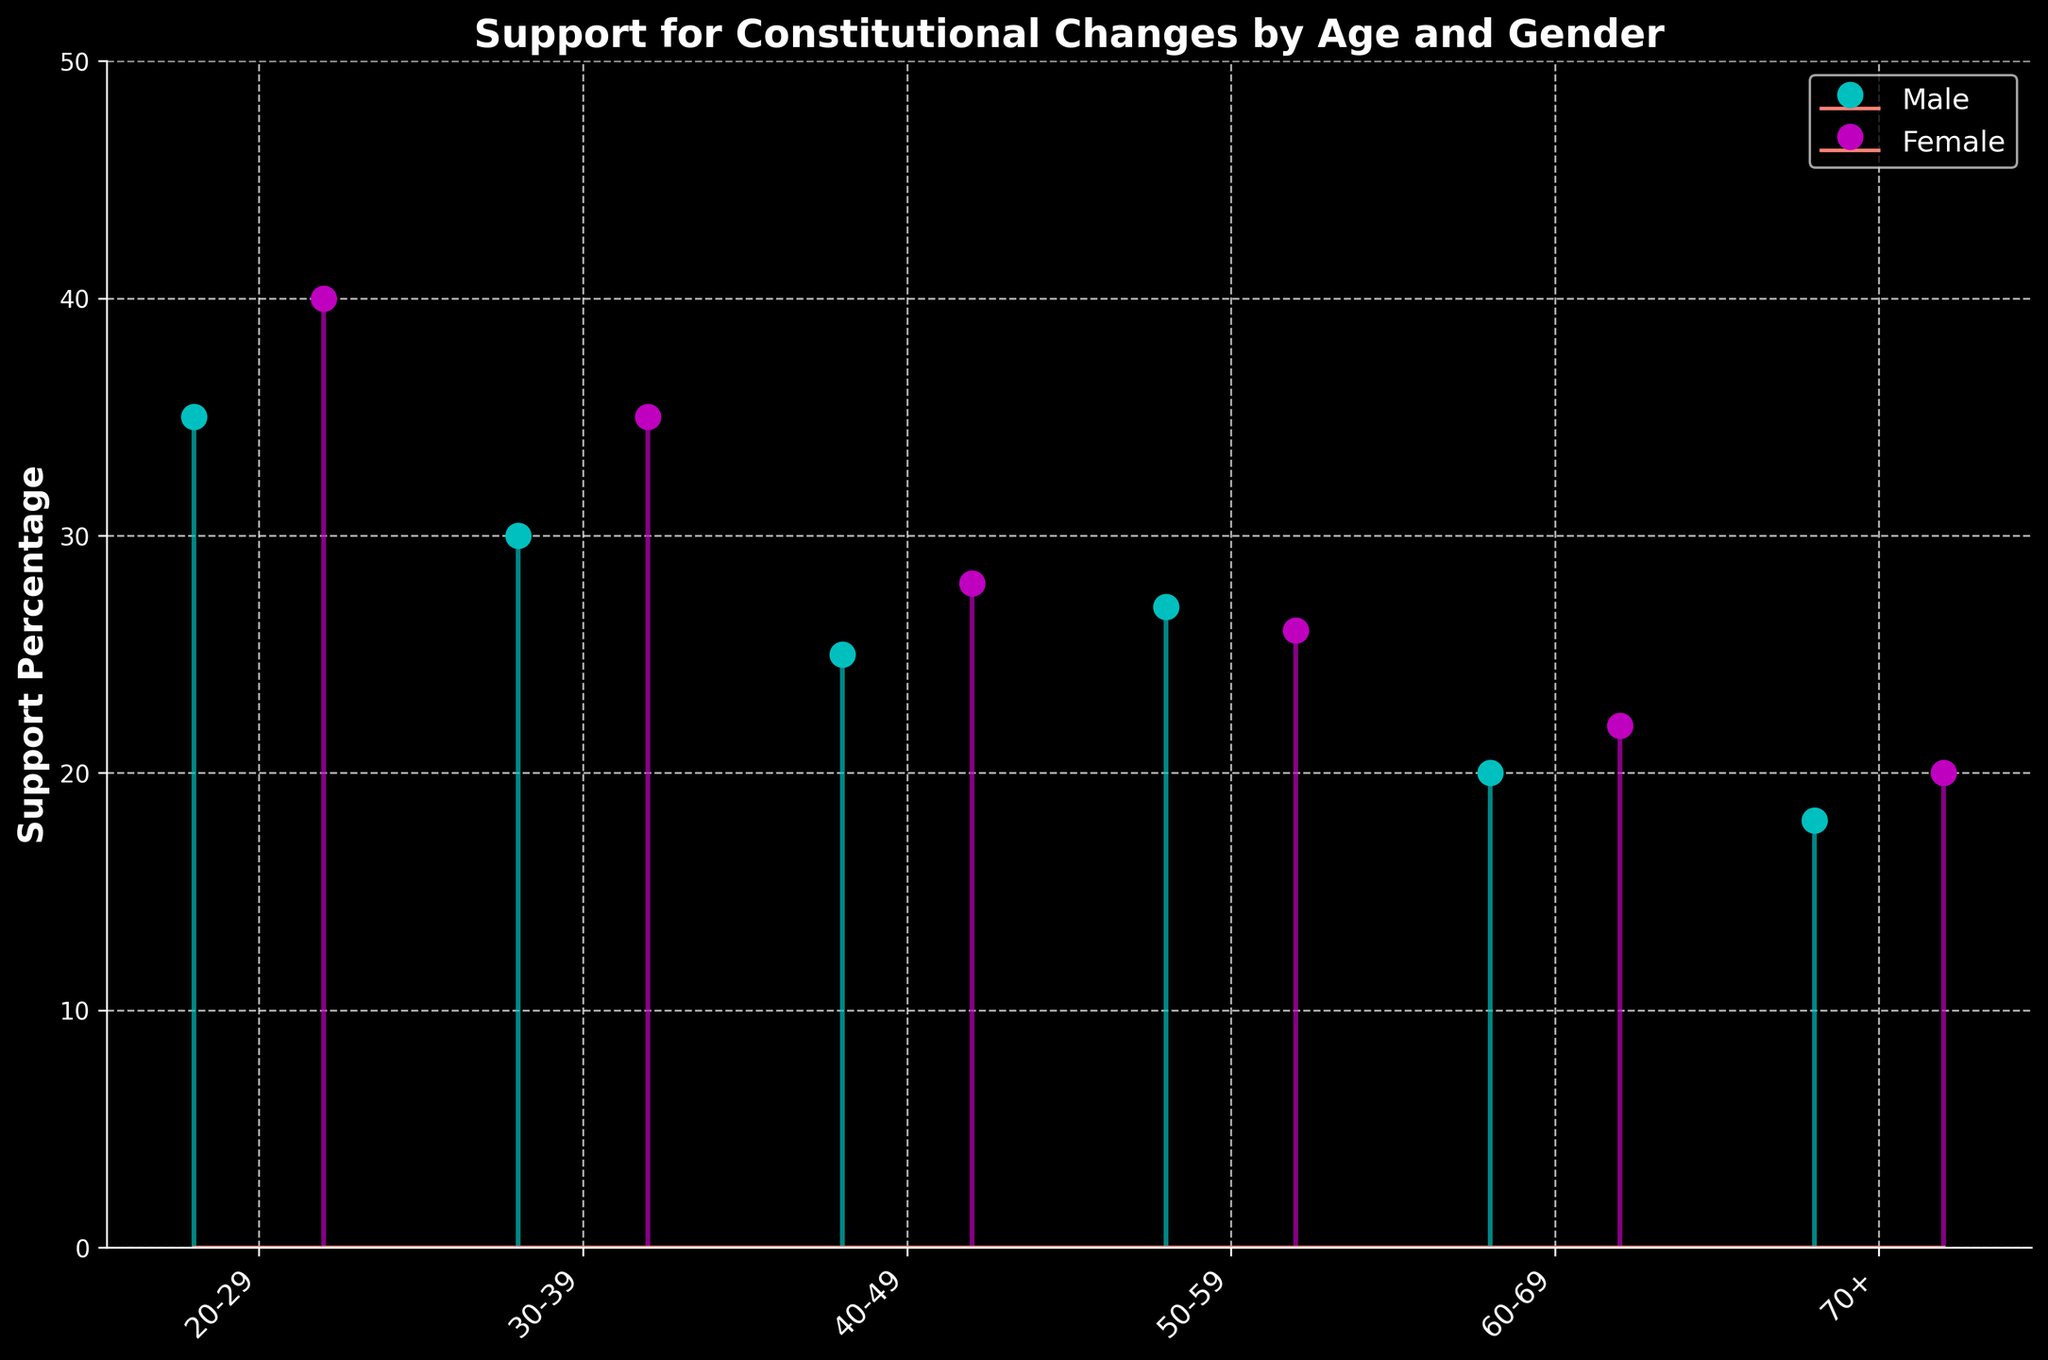What's the title of the figure? The title of the figure is typically found at the top, clearly indicating what the graph represents. In this case, the title is written in bold.
Answer: Support for Constitutional Changes by Age and Gender Which age group of males has the highest support percentage? Examine the height of the lines corresponding to male support across different age groups. The highest line indicates the highest support percentage.
Answer: 20-29 How do the support percentages for males in the 20-29 and 60-69 age groups compare? Identify the data points for males in the 20-29 and 60-69 age groups, then compare their heights.
Answer: 20-29: 35, 60-69: 20 What is the range of support percentages for females across all age groups? Find the highest and lowest support percentages for females across all age groups, then calculate the difference.
Answer: 40 - 20 = 20 Which age group has the smallest difference in support percentage between males and females? Subtract the support percentages of males and females for each age group and find the age group with the smallest absolute difference.
Answer: 50-59 (1%) How does the support percentage of females in the 30-39 age group compare to the average support percentage of females across all age groups? Find the support percentage for females in the 30-39 age group. Calculate the mean support percentage for females across all age groups by summing their support percentages and dividing by the number of age groups. Compare the two values.
Answer: 30-39: 35, average: (40+35+28+26+22+20)/6 = 171/6 ≈ 28.5 Do males or females show a higher variation in support percentages across the age groups? Calculate the range for both males and females by finding the difference between the highest and lowest support percentages within their respective groups. Compare the two ranges.
Answer: Females (20), Males (17) At what age does female support drop below the support percentage of males in the 20-29 age group? Check the support percentages of males in the 20-29 age group. Then, find the age group where the female support percentage first drops below this value.
Answer: 40-49 Is there any age group where the support percentage is equal between males and females? Check each age group to see if the support percentages for males and females are the same.
Answer: No 